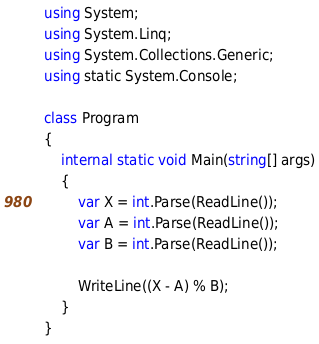Convert code to text. <code><loc_0><loc_0><loc_500><loc_500><_C#_>using System;
using System.Linq;
using System.Collections.Generic;
using static System.Console;

class Program
{
    internal static void Main(string[] args)
    {
        var X = int.Parse(ReadLine());
        var A = int.Parse(ReadLine());
        var B = int.Parse(ReadLine());

        WriteLine((X - A) % B);
    }
}
</code> 